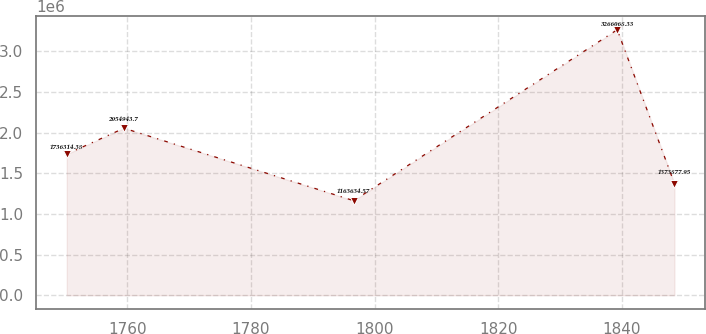<chart> <loc_0><loc_0><loc_500><loc_500><line_chart><ecel><fcel>Unnamed: 1<nl><fcel>1750.21<fcel>1.73631e+06<nl><fcel>1759.47<fcel>2.05494e+06<nl><fcel>1796.62<fcel>1.16363e+06<nl><fcel>1839.25<fcel>3.26607e+06<nl><fcel>1848.51<fcel>1.37388e+06<nl></chart> 